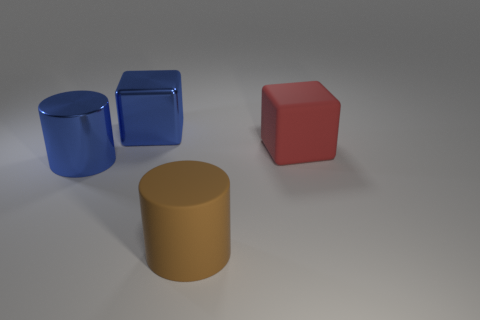What material is the large object on the right side of the matte cylinder?
Provide a short and direct response. Rubber. The other big thing that is the same material as the big brown object is what color?
Make the answer very short. Red. What number of blue metal objects are the same size as the red block?
Offer a terse response. 2. Do the thing behind the matte cube and the big brown cylinder have the same size?
Your response must be concise. Yes. The thing that is on the left side of the large red cube and behind the large blue cylinder has what shape?
Your answer should be very brief. Cube. Are there any cubes to the left of the metallic block?
Ensure brevity in your answer.  No. Is there any other thing that is the same shape as the red object?
Your response must be concise. Yes. Is the shape of the red object the same as the brown thing?
Your answer should be compact. No. Are there the same number of blue shiny cylinders that are to the right of the big blue metal cube and blue things that are in front of the red matte block?
Give a very brief answer. No. What number of other objects are there of the same material as the brown cylinder?
Your answer should be compact. 1. 